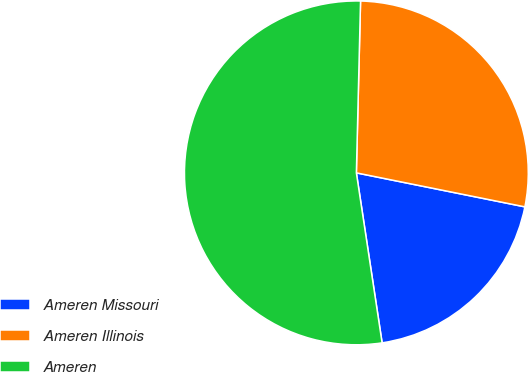<chart> <loc_0><loc_0><loc_500><loc_500><pie_chart><fcel>Ameren Missouri<fcel>Ameren Illinois<fcel>Ameren<nl><fcel>19.44%<fcel>27.78%<fcel>52.78%<nl></chart> 